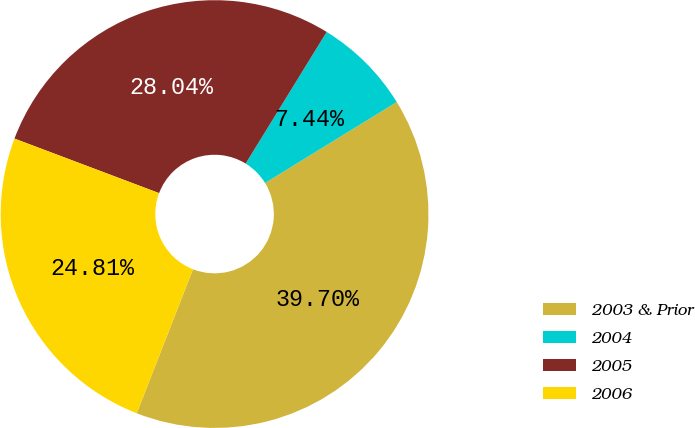Convert chart. <chart><loc_0><loc_0><loc_500><loc_500><pie_chart><fcel>2003 & Prior<fcel>2004<fcel>2005<fcel>2006<nl><fcel>39.7%<fcel>7.44%<fcel>28.04%<fcel>24.81%<nl></chart> 